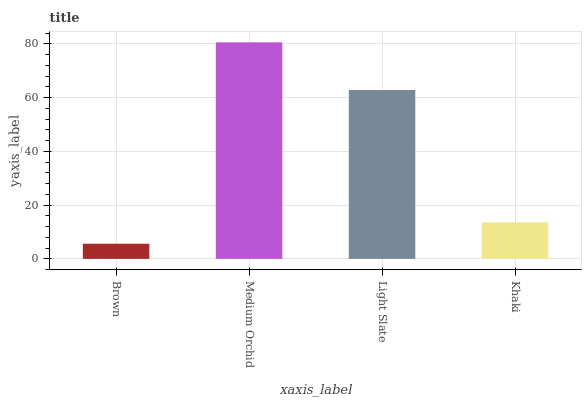Is Brown the minimum?
Answer yes or no. Yes. Is Medium Orchid the maximum?
Answer yes or no. Yes. Is Light Slate the minimum?
Answer yes or no. No. Is Light Slate the maximum?
Answer yes or no. No. Is Medium Orchid greater than Light Slate?
Answer yes or no. Yes. Is Light Slate less than Medium Orchid?
Answer yes or no. Yes. Is Light Slate greater than Medium Orchid?
Answer yes or no. No. Is Medium Orchid less than Light Slate?
Answer yes or no. No. Is Light Slate the high median?
Answer yes or no. Yes. Is Khaki the low median?
Answer yes or no. Yes. Is Khaki the high median?
Answer yes or no. No. Is Medium Orchid the low median?
Answer yes or no. No. 